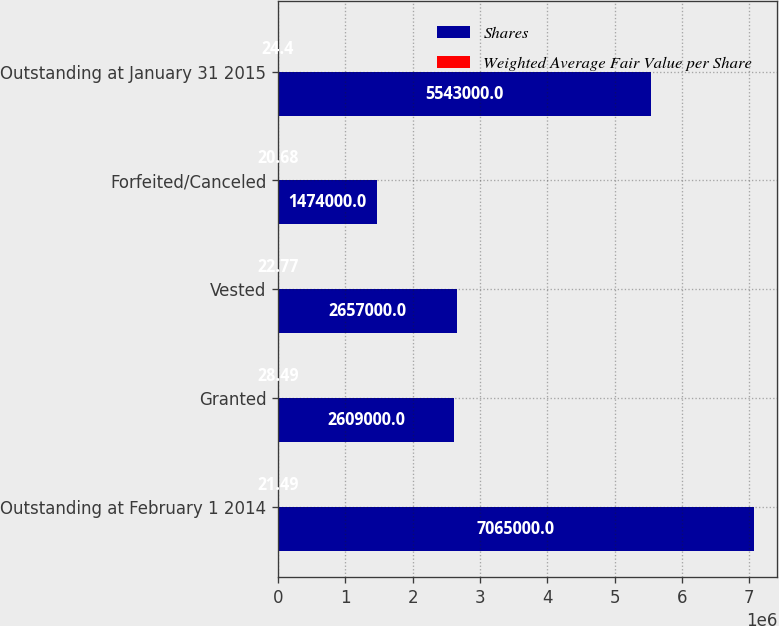Convert chart to OTSL. <chart><loc_0><loc_0><loc_500><loc_500><stacked_bar_chart><ecel><fcel>Outstanding at February 1 2014<fcel>Granted<fcel>Vested<fcel>Forfeited/Canceled<fcel>Outstanding at January 31 2015<nl><fcel>Shares<fcel>7.065e+06<fcel>2.609e+06<fcel>2.657e+06<fcel>1.474e+06<fcel>5.543e+06<nl><fcel>Weighted Average Fair Value per Share<fcel>21.49<fcel>28.49<fcel>22.77<fcel>20.68<fcel>24.4<nl></chart> 